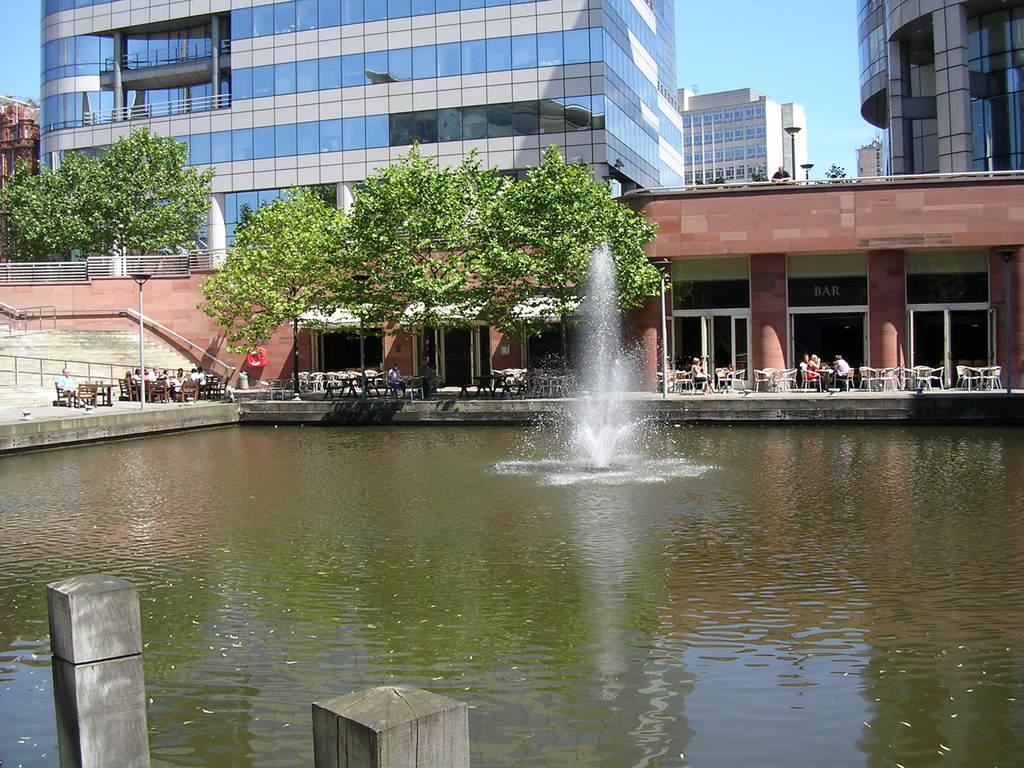In one or two sentences, can you explain what this image depicts? In this image we can see there are buildings and there are persons sitting on the chairs and there are windows, ground, light poles, railing and pillars. And we can see the water and a fountain. And there are trees and the sky. 